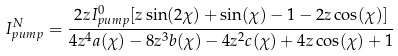Convert formula to latex. <formula><loc_0><loc_0><loc_500><loc_500>I ^ { N } _ { p u m p } = \frac { 2 z I ^ { 0 } _ { p u m p } [ z \sin ( 2 \chi ) + \sin ( \chi ) - 1 - 2 z \cos ( \chi ) ] } { 4 z ^ { 4 } a ( \chi ) - 8 z ^ { 3 } b ( \chi ) - 4 z ^ { 2 } c ( \chi ) + 4 z \cos ( \chi ) + 1 }</formula> 